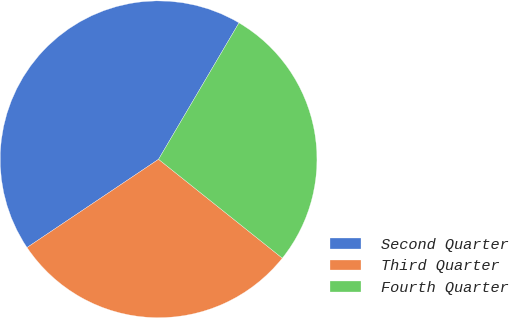Convert chart to OTSL. <chart><loc_0><loc_0><loc_500><loc_500><pie_chart><fcel>Second Quarter<fcel>Third Quarter<fcel>Fourth Quarter<nl><fcel>42.88%<fcel>29.87%<fcel>27.25%<nl></chart> 